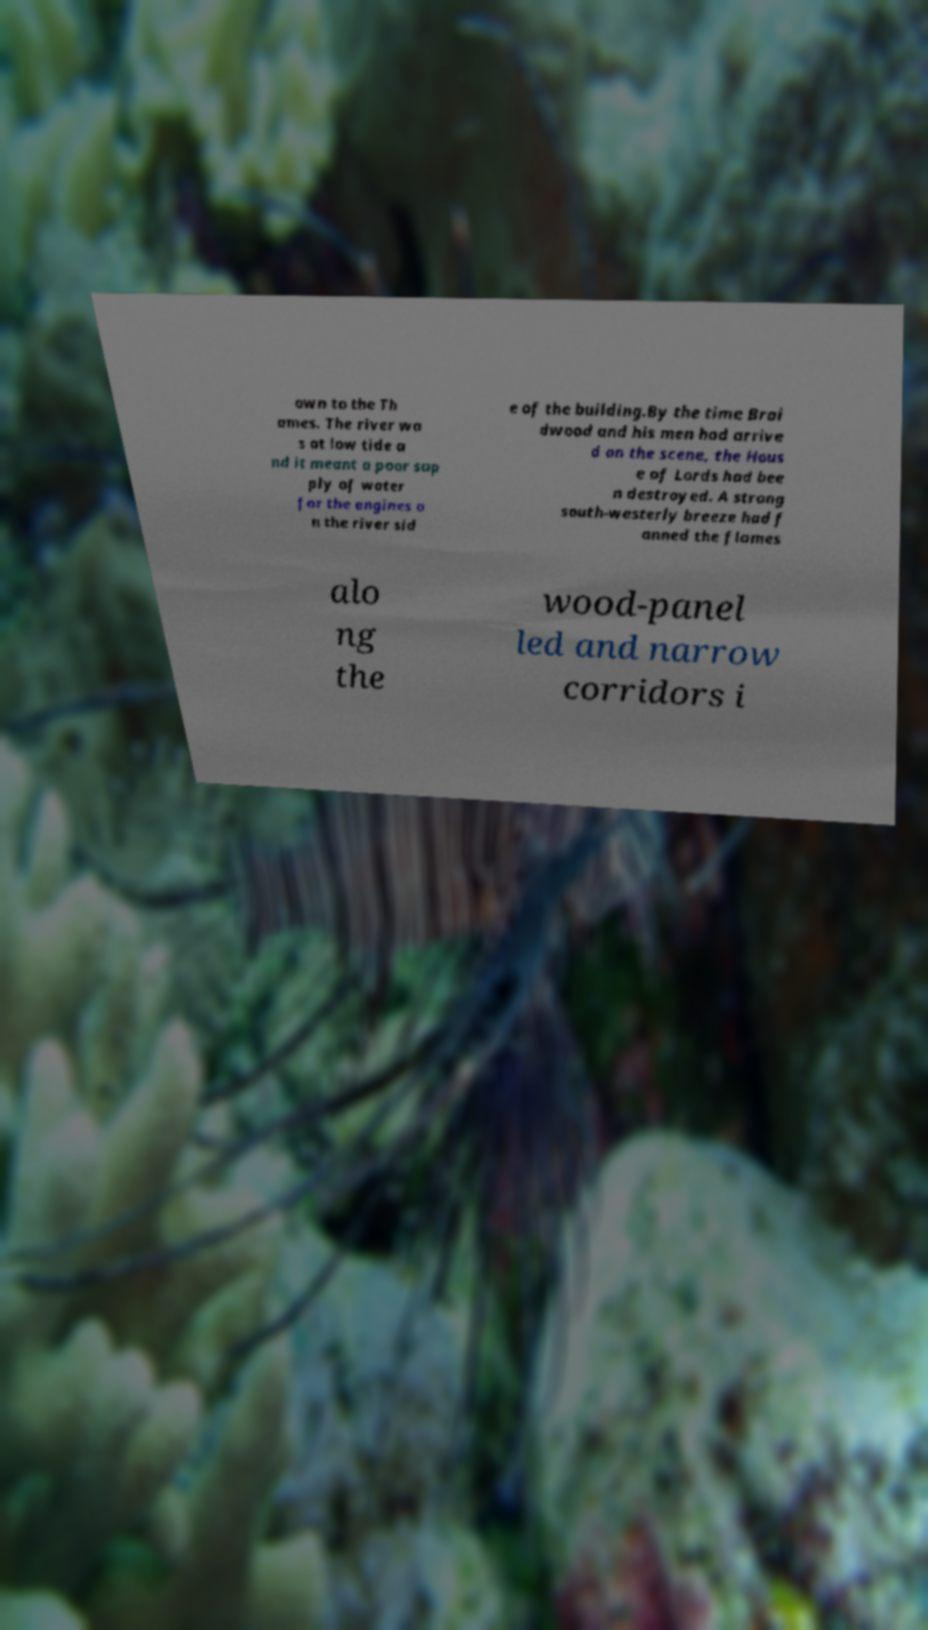Could you extract and type out the text from this image? own to the Th ames. The river wa s at low tide a nd it meant a poor sup ply of water for the engines o n the river sid e of the building.By the time Brai dwood and his men had arrive d on the scene, the Hous e of Lords had bee n destroyed. A strong south-westerly breeze had f anned the flames alo ng the wood-panel led and narrow corridors i 